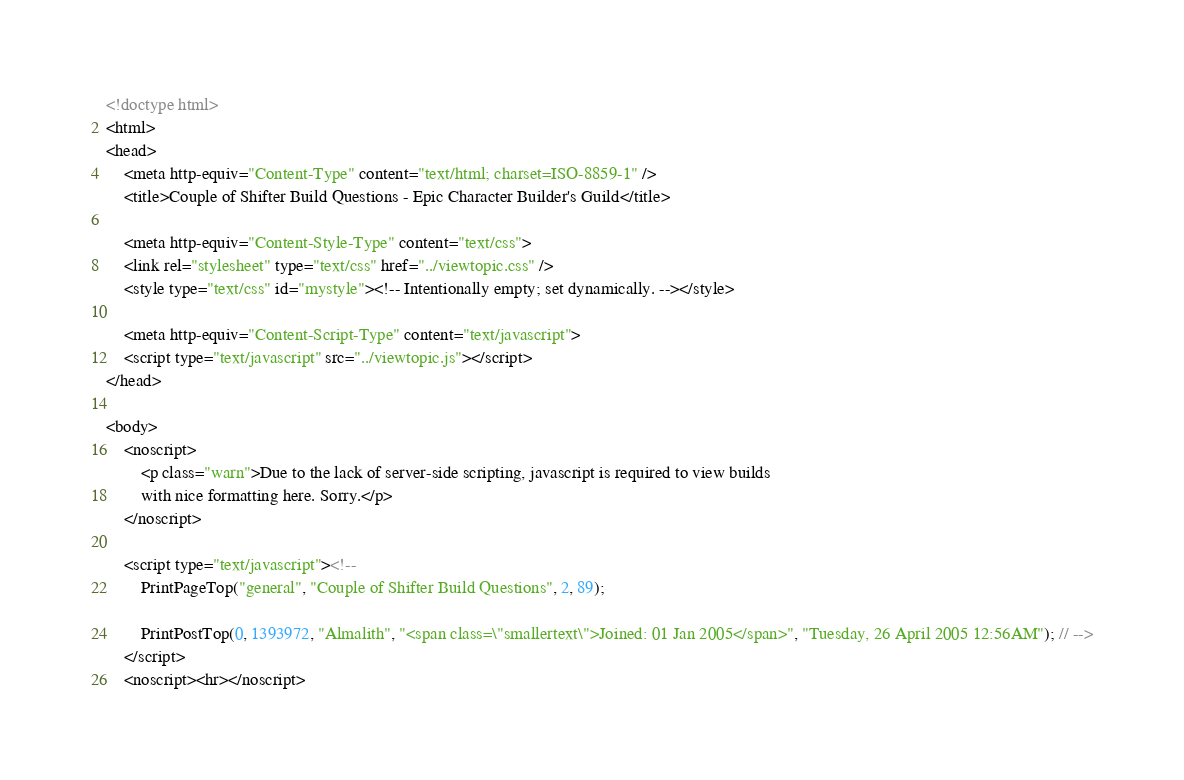<code> <loc_0><loc_0><loc_500><loc_500><_HTML_><!doctype html>
<html>
<head>
    <meta http-equiv="Content-Type" content="text/html; charset=ISO-8859-1" />
    <title>Couple of Shifter Build Questions - Epic Character Builder's Guild</title>

    <meta http-equiv="Content-Style-Type" content="text/css">
    <link rel="stylesheet" type="text/css" href="../viewtopic.css" />
    <style type="text/css" id="mystyle"><!-- Intentionally empty; set dynamically. --></style>

    <meta http-equiv="Content-Script-Type" content="text/javascript">
    <script type="text/javascript" src="../viewtopic.js"></script>
</head>

<body>
    <noscript>
        <p class="warn">Due to the lack of server-side scripting, javascript is required to view builds
        with nice formatting here. Sorry.</p>
    </noscript>

    <script type="text/javascript"><!--
        PrintPageTop("general", "Couple of Shifter Build Questions", 2, 89);

        PrintPostTop(0, 1393972, "Almalith", "<span class=\"smallertext\">Joined: 01 Jan 2005</span>", "Tuesday, 26 April 2005 12:56AM"); // -->
    </script>
    <noscript><hr></noscript></code> 